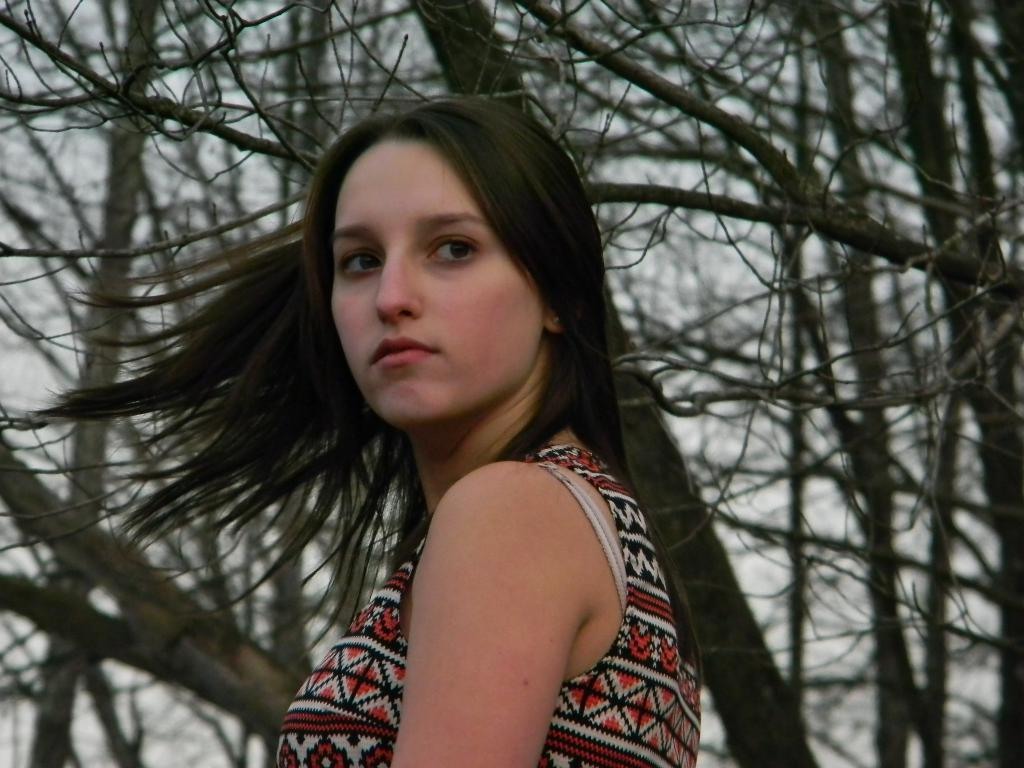Who is present in the image? There is a woman in the image. What type of natural vegetation can be seen in the image? There are trees in the image. What part of the natural environment is visible in the image? The sky is visible in the background of the image. What type of animal can be seen walking in the image? There is no animal, such as a giraffe, present in the image. What type of drug can be seen being consumed in the image? There is no drug present in the image; it is a woman and trees in the image. 